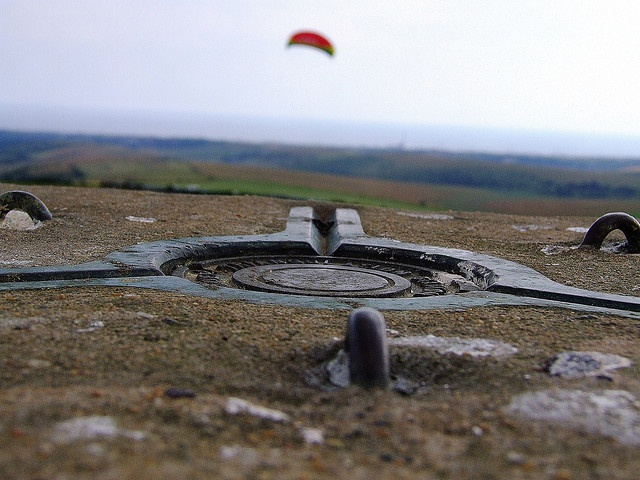Describe the objects in this image and their specific colors. I can see a kite in lavender, brown, olive, and darkgray tones in this image. 